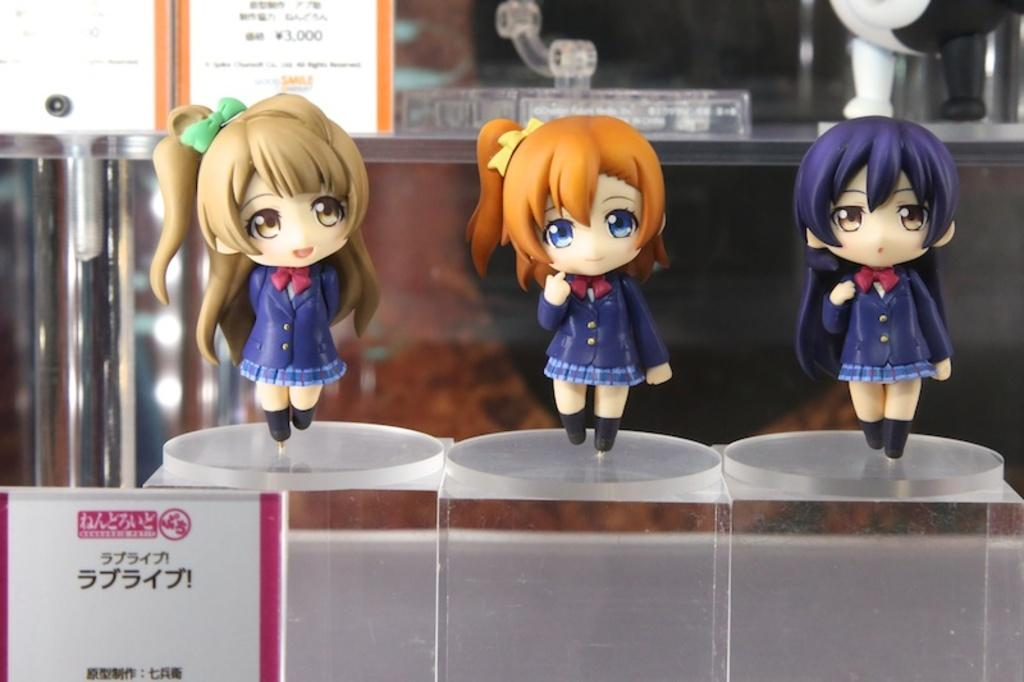What objects can be seen on the glass surface in the image? There are three toys on a glass surface in the image. What can be seen in the background of the image? There are boards visible in the background of the image. Are there any other objects present in the background of the image? Yes, there are some objects present in the background of the image. What type of camp can be seen in the image? There is no camp present in the image; it features three toys on a glass surface and objects in the background. 